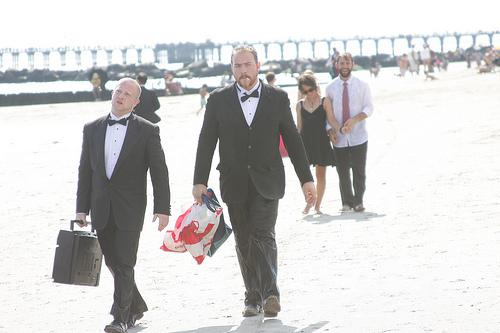Question: what are they wearing?
Choices:
A. Shorts.
B. Swimsuits.
C. Costumes.
D. Suits.
Answer with the letter. Answer: D Question: where is this scene?
Choices:
A. Park.
B. Backyard.
C. Beach.
D. School.
Answer with the letter. Answer: C Question: how bright is it?
Choices:
A. Not at all.
B. Very bright.
C. Medium.
D. Brighter than average.
Answer with the letter. Answer: B 